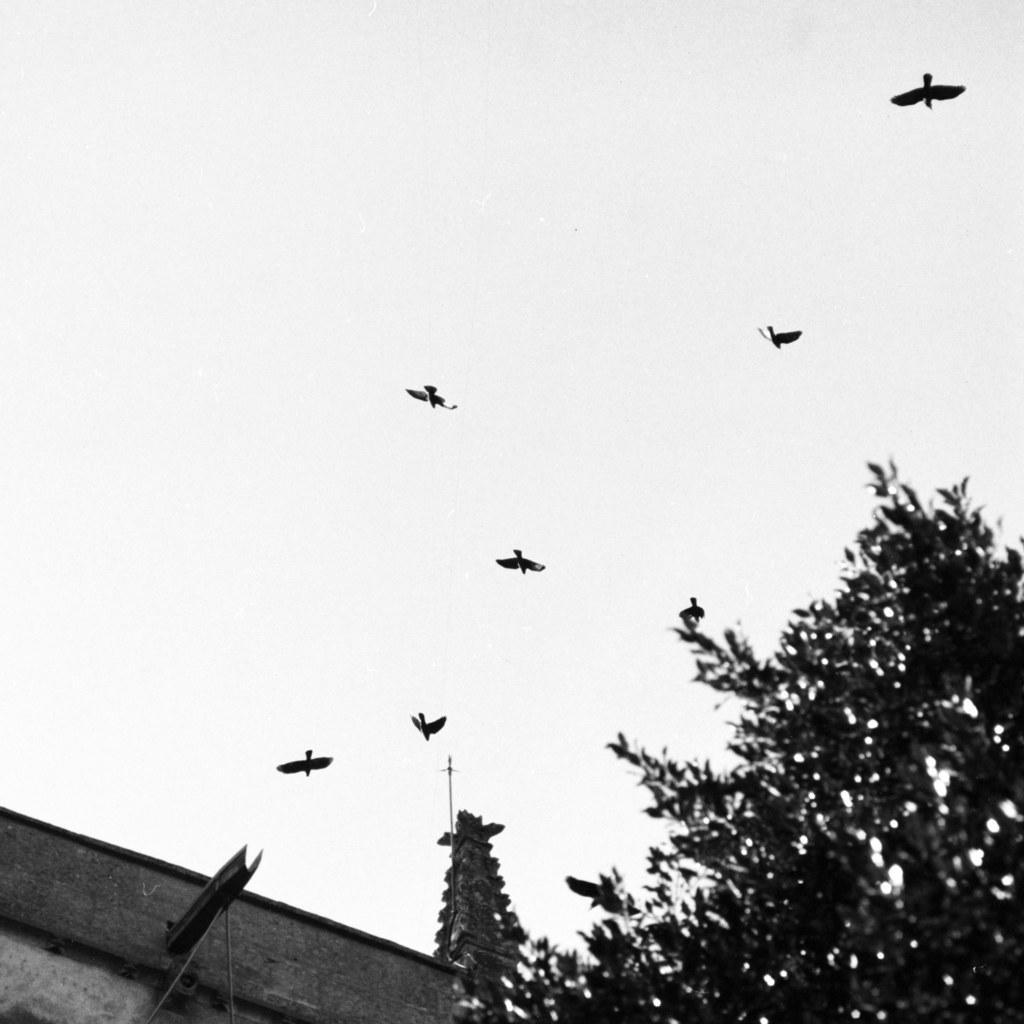What is happening in the sky in the image? There are birds flying in the sky in the image. What type of natural vegetation can be seen in the image? There are trees visible in the image. What type of man-made structure is present in the image? There is a building in the image. What type of skirt is hanging on the tree in the image? There is no skirt present in the image; it features birds flying in the sky, trees, and a building. How does the image convey a sense of hate or animosity? The image does not convey any sense of hate or animosity; it simply depicts birds, trees, and a building. 